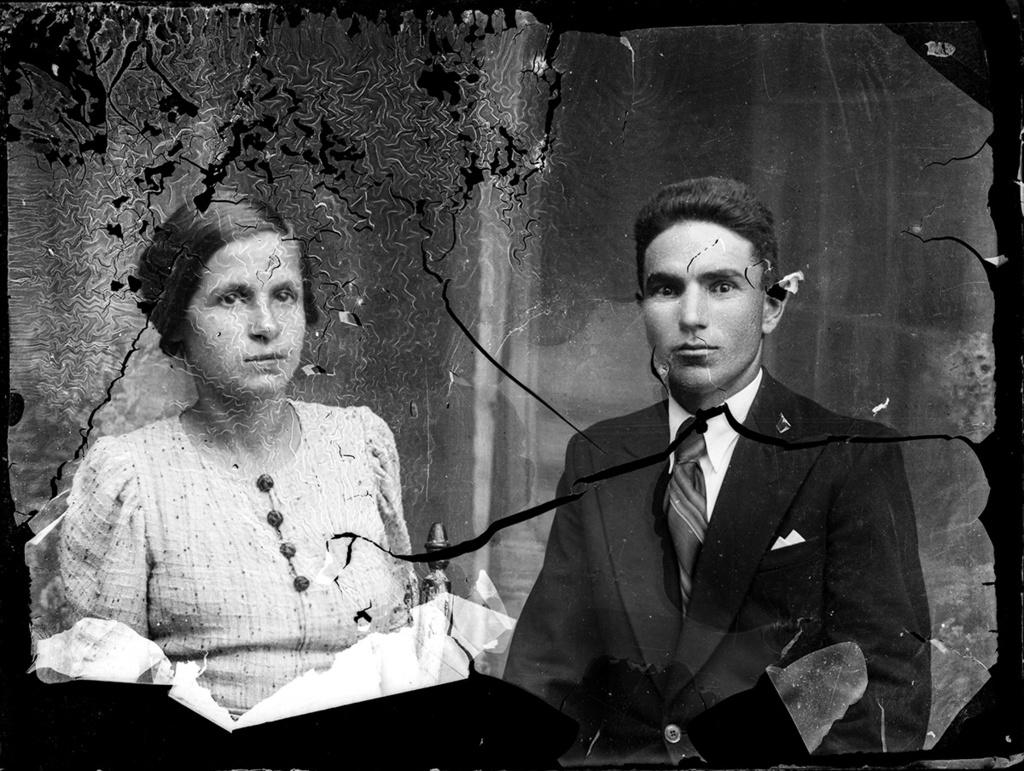What is the main object in the image? There is a paper in the image. Are there any people present in the image? Yes, there are people standing in the image. What is the color scheme of the image? The image is in black and white color. Can you see a beetle running across the paper in the image? There is no beetle present in the image, and therefore no such activity can be observed. 